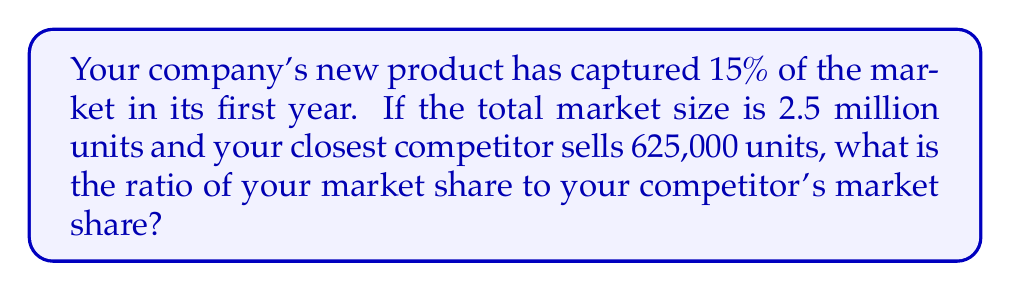Could you help me with this problem? Let's break this down step-by-step:

1. Calculate your company's sales:
   * Total market size = 2.5 million units
   * Your market share = 15% = 0.15
   * Your sales = $0.15 \times 2,500,000 = 375,000$ units

2. Calculate your competitor's market share:
   * Competitor's sales = 625,000 units
   * Competitor's market share = $\frac{625,000}{2,500,000} = 0.25 = 25\%$

3. Express the ratio of your market share to your competitor's:
   * Your market share : Competitor's market share
   * $15\% : 25\%$
   * Simplify this ratio by dividing both numbers by their greatest common divisor (5):
     $\frac{15}{5} : \frac{25}{5} = 3 : 5$

Therefore, the ratio of your market share to your competitor's market share is 3:5.
Answer: 3:5 